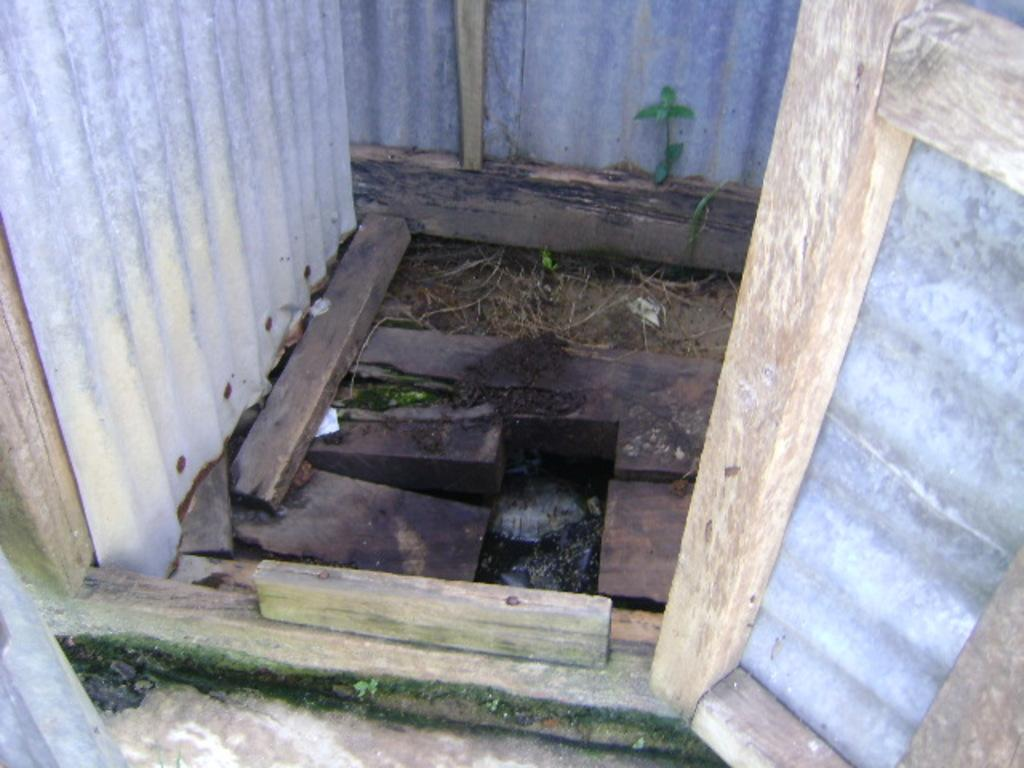What type of material is used for the logs in the image? The logs in the image are made of wood. What kind of structure is present in the image? There is a metal sheet room in the image. What type of toy can be seen on the floor in the image? There is no floor or toy present in the image; it only features wooden logs and a metal sheet room. 